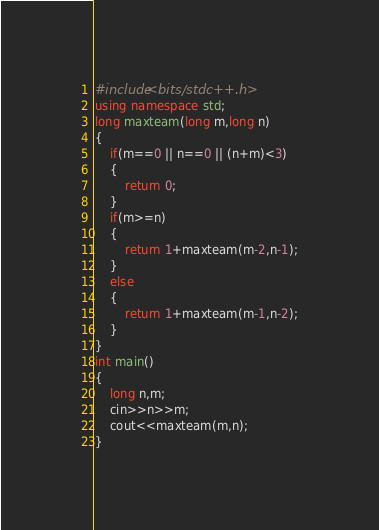Convert code to text. <code><loc_0><loc_0><loc_500><loc_500><_C++_>#include<bits/stdc++.h>
using namespace std;
long maxteam(long m,long n)
{
	if(m==0 || n==0 || (n+m)<3)
	{
		return 0;
	}
	if(m>=n)
	{
		return 1+maxteam(m-2,n-1);
	}
	else
	{
		return 1+maxteam(m-1,n-2);
	}
}
int main()
{
	long n,m;
	cin>>n>>m;
	cout<<maxteam(m,n);
}</code> 